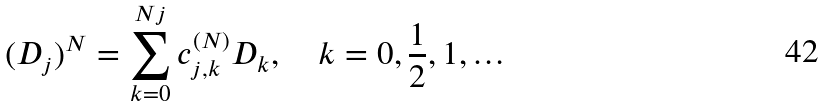<formula> <loc_0><loc_0><loc_500><loc_500>( D _ { j } ) ^ { N } = \sum _ { k = 0 } ^ { N j } c _ { j , k } ^ { ( N ) } D _ { k } , \quad k = 0 , \frac { 1 } { 2 } , 1 , \dots</formula> 